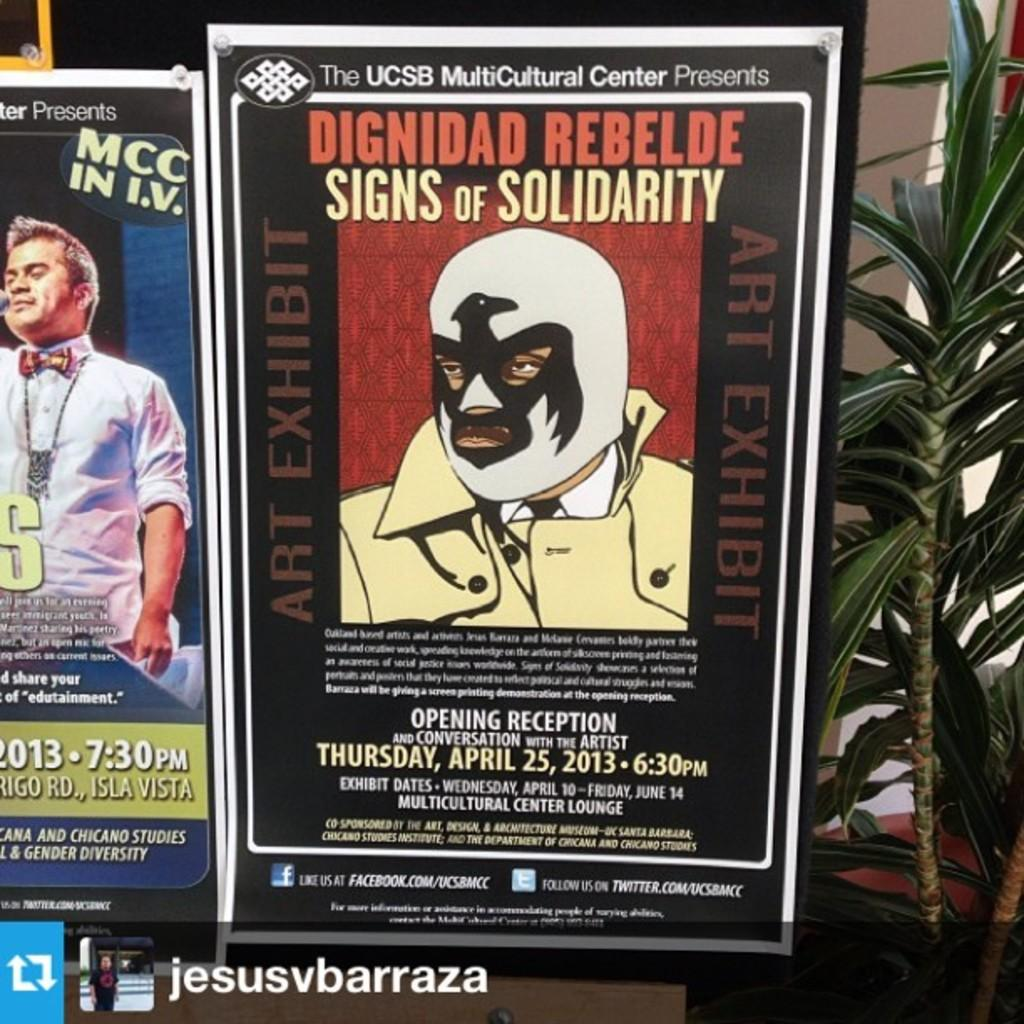What objects are present in the image that are supporting something? There are two posts in the image that are supporting a board. What is the board being used for in the image? The provided facts do not specify the purpose of the board. Can you describe any vegetation visible in the image? Yes, there is a part of a plant visible in the image. Where are the tomatoes growing in the image? There are no tomatoes present in the image. What type of loaf is being displayed on the board in the image? There is no loaf present in the image. 